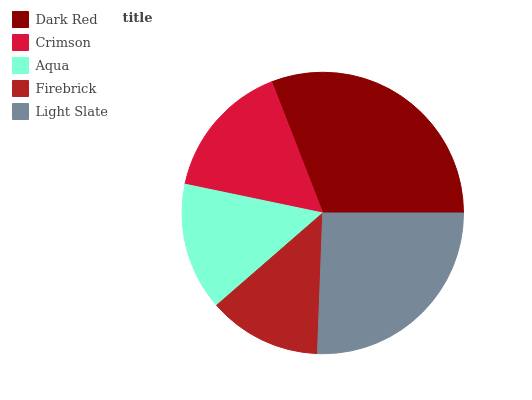Is Firebrick the minimum?
Answer yes or no. Yes. Is Dark Red the maximum?
Answer yes or no. Yes. Is Crimson the minimum?
Answer yes or no. No. Is Crimson the maximum?
Answer yes or no. No. Is Dark Red greater than Crimson?
Answer yes or no. Yes. Is Crimson less than Dark Red?
Answer yes or no. Yes. Is Crimson greater than Dark Red?
Answer yes or no. No. Is Dark Red less than Crimson?
Answer yes or no. No. Is Crimson the high median?
Answer yes or no. Yes. Is Crimson the low median?
Answer yes or no. Yes. Is Dark Red the high median?
Answer yes or no. No. Is Light Slate the low median?
Answer yes or no. No. 